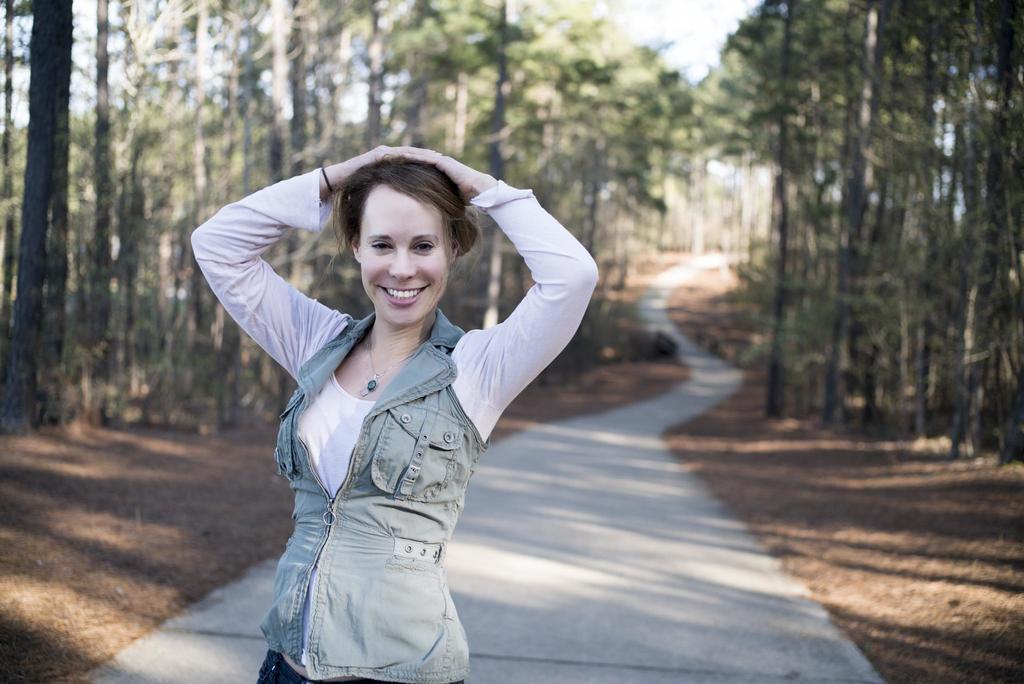Could you give a brief overview of what you see in this image? In this image there is a person standing, there is soil, there are trees truncated towards the right of the image, there are trees truncated towards the left of the image, in this image there is the sky. 